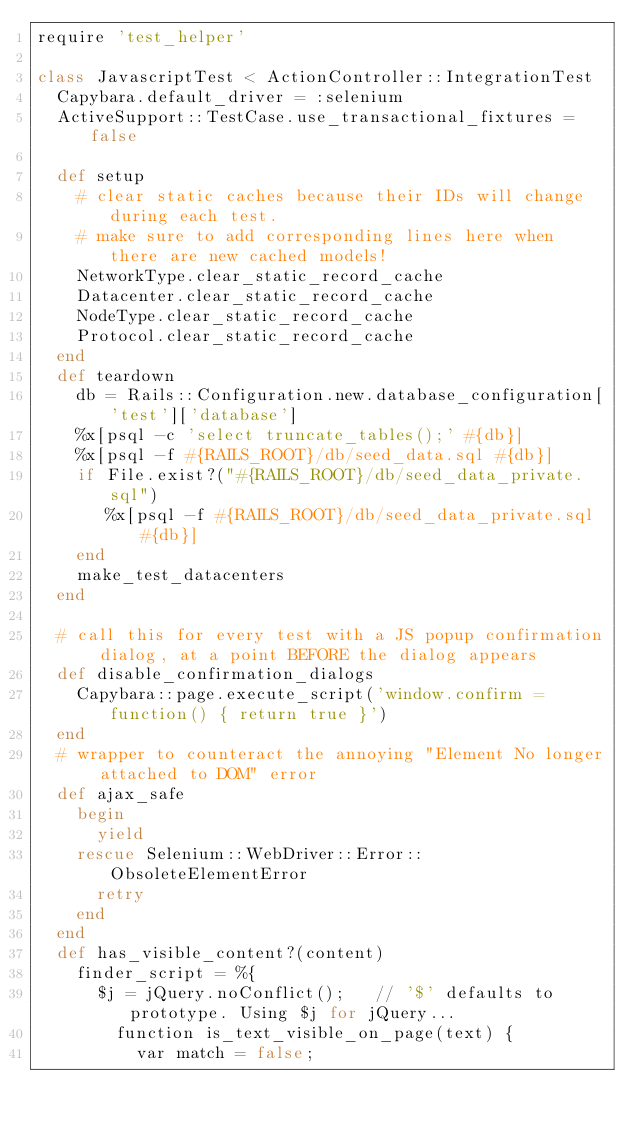<code> <loc_0><loc_0><loc_500><loc_500><_Ruby_>require 'test_helper'

class JavascriptTest < ActionController::IntegrationTest
  Capybara.default_driver = :selenium
  ActiveSupport::TestCase.use_transactional_fixtures = false

  def setup 
    # clear static caches because their IDs will change during each test.
    # make sure to add corresponding lines here when there are new cached models!
    NetworkType.clear_static_record_cache
    Datacenter.clear_static_record_cache
    NodeType.clear_static_record_cache
    Protocol.clear_static_record_cache
  end
  def teardown
    db = Rails::Configuration.new.database_configuration['test']['database']
    %x[psql -c 'select truncate_tables();' #{db}]
    %x[psql -f #{RAILS_ROOT}/db/seed_data.sql #{db}]
    if File.exist?("#{RAILS_ROOT}/db/seed_data_private.sql")
       %x[psql -f #{RAILS_ROOT}/db/seed_data_private.sql #{db}]
    end
    make_test_datacenters
  end

  # call this for every test with a JS popup confirmation dialog, at a point BEFORE the dialog appears
  def disable_confirmation_dialogs
    Capybara::page.execute_script('window.confirm = function() { return true }')
  end
  # wrapper to counteract the annoying "Element No longer attached to DOM" error
  def ajax_safe
    begin
      yield
    rescue Selenium::WebDriver::Error::ObsoleteElementError
      retry
    end
  end
  def has_visible_content?(content)
    finder_script = %{ 
      $j = jQuery.noConflict();   // '$' defaults to prototype. Using $j for jQuery...
        function is_text_visible_on_page(text) { 
          var match = false; </code> 